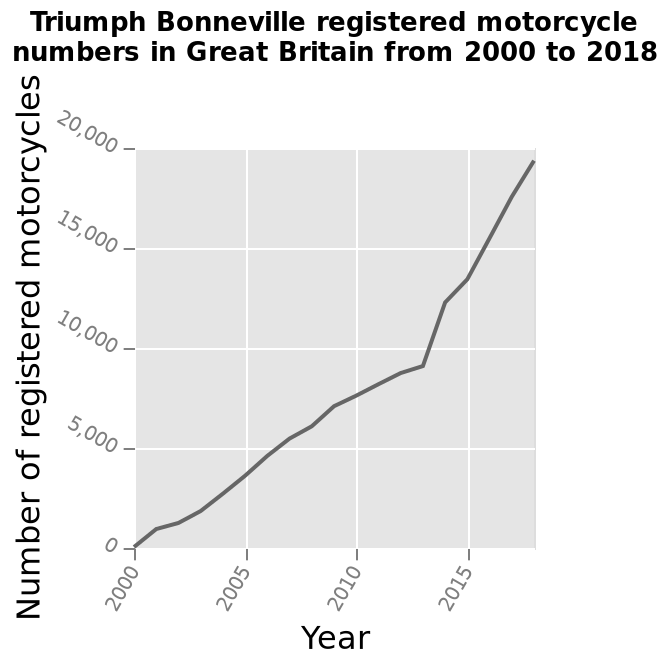<image>
Offer a thorough analysis of the image. The number of Triumph Bonnerville registered motorcycles increased between 2000 and 2018. From 0 such motorcycles being registered in 2000 by 2018 just under 20,000 were registered.Since approximately 2012 the amount of registration has increased at a greater rate than in previous years. When was the first year that Triumph Bonneville motorcycles were registered?  Triumph Bonneville motorcycles were not registered in 2000. Describe the following image in detail This line graph is labeled Triumph Bonneville registered motorcycle numbers in Great Britain from 2000 to 2018. Year is drawn along the x-axis. The y-axis plots Number of registered motorcycles with a linear scale with a minimum of 0 and a maximum of 20,000. What does the y-axis represent in the graph? The y-axis represents the number of registered motorcycles. Did the number of Triumph Bonnerville registered motorcycles remained unchanged between 2000 and 2018? No.The number of Triumph Bonnerville registered motorcycles increased between 2000 and 2018. From 0 such motorcycles being registered in 2000 by 2018 just under 20,000 were registered.Since approximately 2012 the amount of registration has increased at a greater rate than in previous years. 